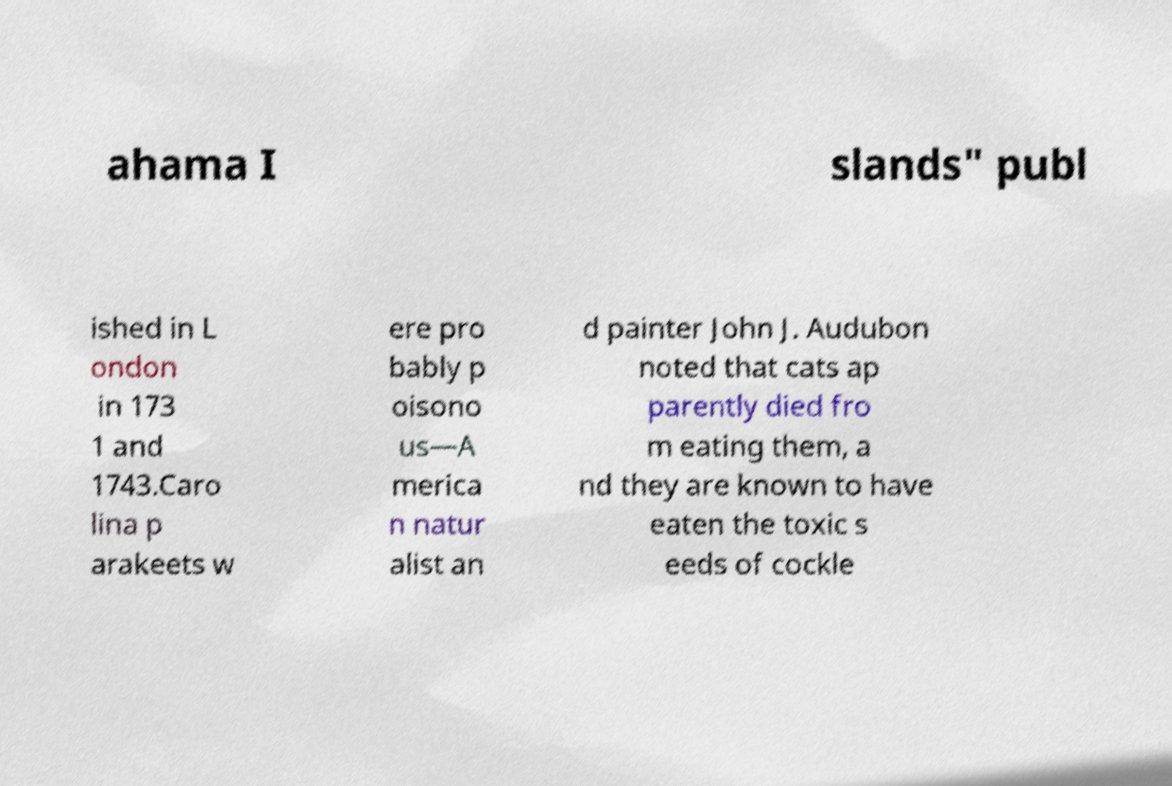Can you read and provide the text displayed in the image?This photo seems to have some interesting text. Can you extract and type it out for me? ahama I slands" publ ished in L ondon in 173 1 and 1743.Caro lina p arakeets w ere pro bably p oisono us—A merica n natur alist an d painter John J. Audubon noted that cats ap parently died fro m eating them, a nd they are known to have eaten the toxic s eeds of cockle 